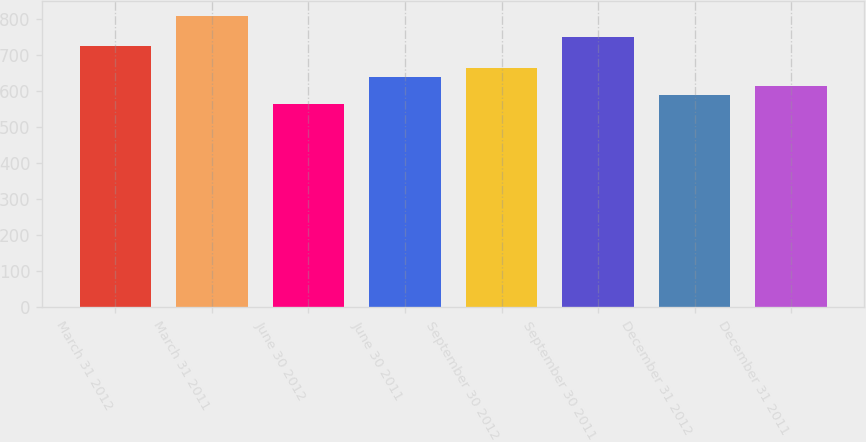<chart> <loc_0><loc_0><loc_500><loc_500><bar_chart><fcel>March 31 2012<fcel>March 31 2011<fcel>June 30 2012<fcel>June 30 2011<fcel>September 30 2012<fcel>September 30 2011<fcel>December 31 2012<fcel>December 31 2011<nl><fcel>724<fcel>808<fcel>564<fcel>637.8<fcel>662.2<fcel>748.4<fcel>589<fcel>613.4<nl></chart> 